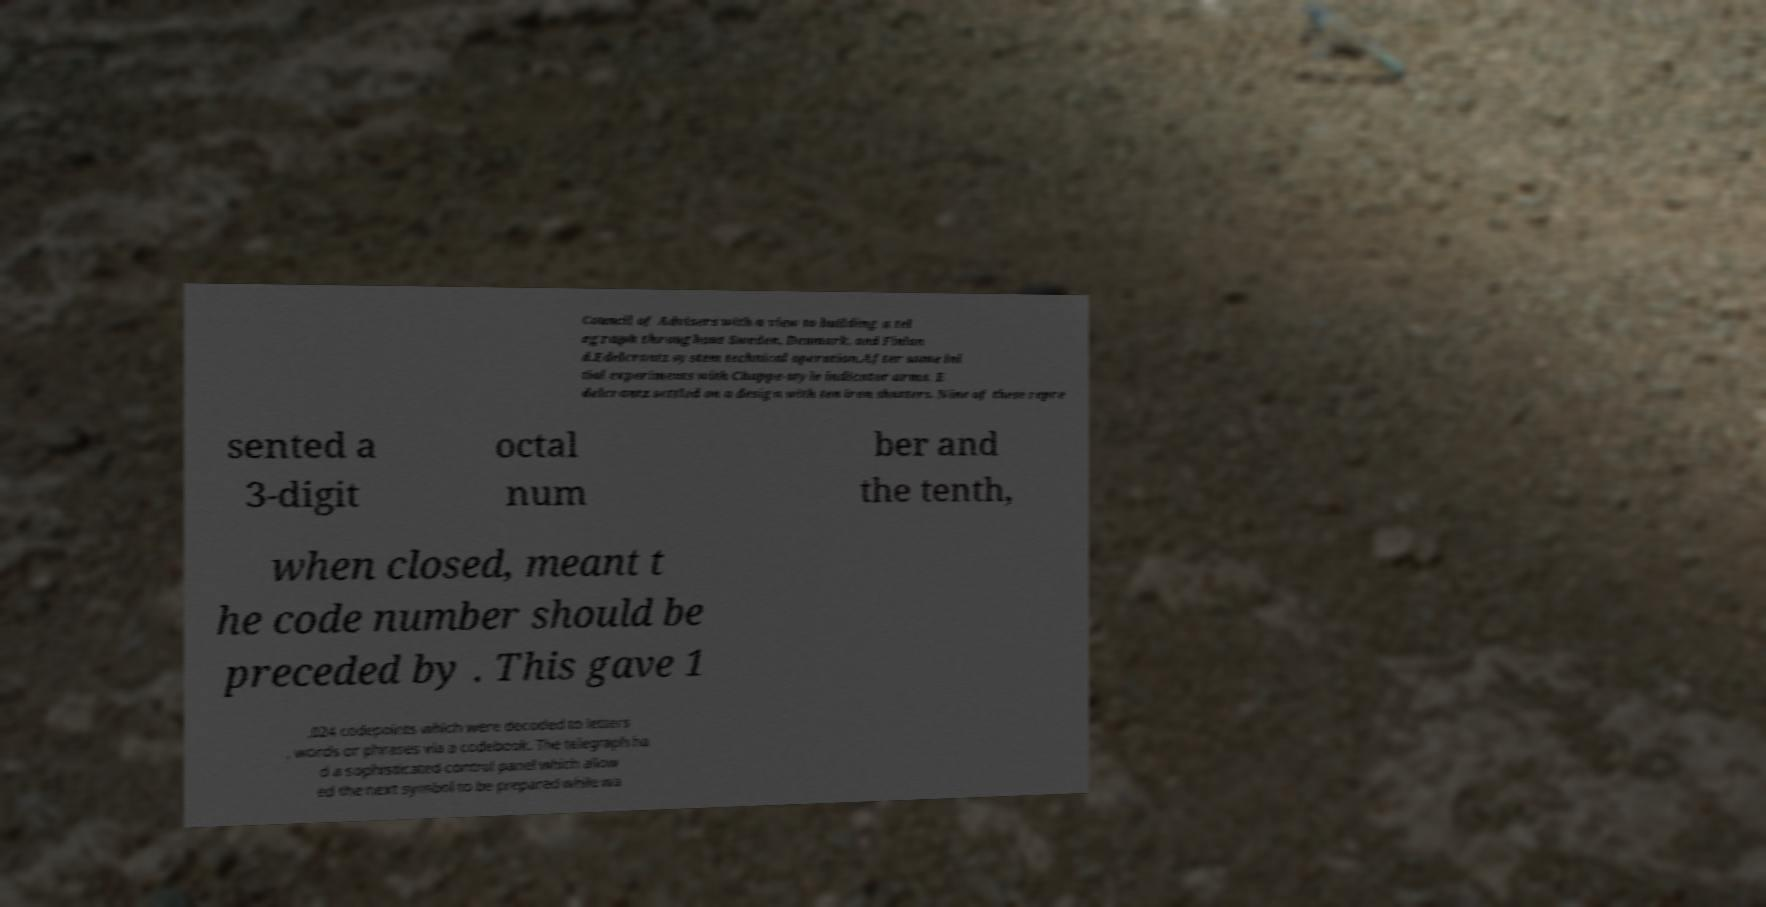Can you read and provide the text displayed in the image?This photo seems to have some interesting text. Can you extract and type it out for me? Council of Advisers with a view to building a tel egraph throughout Sweden, Denmark, and Finlan d.Edelcrantz system technical operation.After some ini tial experiments with Chappe-style indicator arms, E delcrantz settled on a design with ten iron shutters. Nine of these repre sented a 3-digit octal num ber and the tenth, when closed, meant t he code number should be preceded by . This gave 1 ,024 codepoints which were decoded to letters , words or phrases via a codebook. The telegraph ha d a sophisticated control panel which allow ed the next symbol to be prepared while wa 